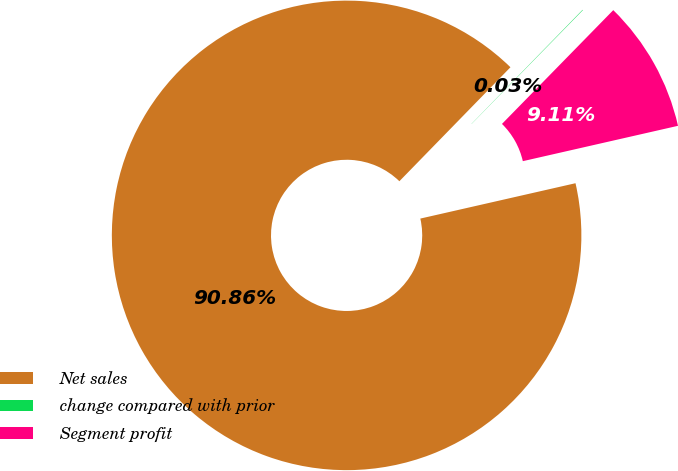Convert chart. <chart><loc_0><loc_0><loc_500><loc_500><pie_chart><fcel>Net sales<fcel>change compared with prior<fcel>Segment profit<nl><fcel>90.86%<fcel>0.03%<fcel>9.11%<nl></chart> 